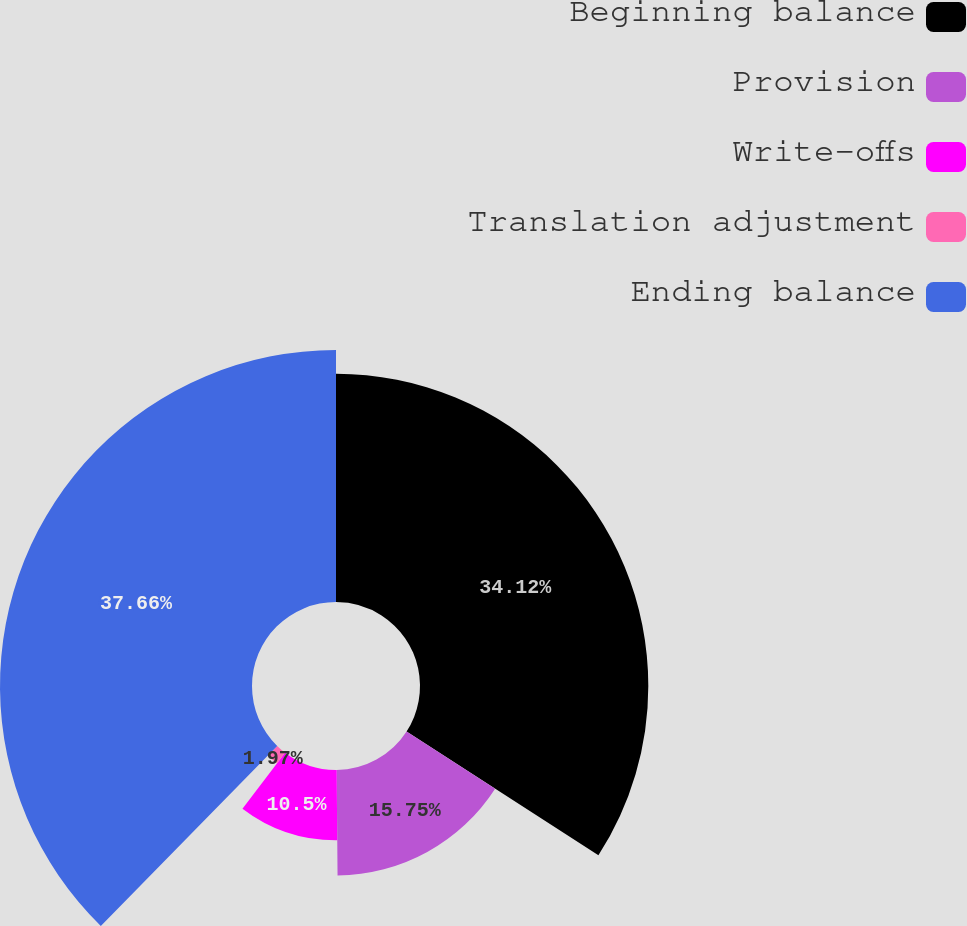Convert chart to OTSL. <chart><loc_0><loc_0><loc_500><loc_500><pie_chart><fcel>Beginning balance<fcel>Provision<fcel>Write-offs<fcel>Translation adjustment<fcel>Ending balance<nl><fcel>34.12%<fcel>15.75%<fcel>10.5%<fcel>1.97%<fcel>37.66%<nl></chart> 